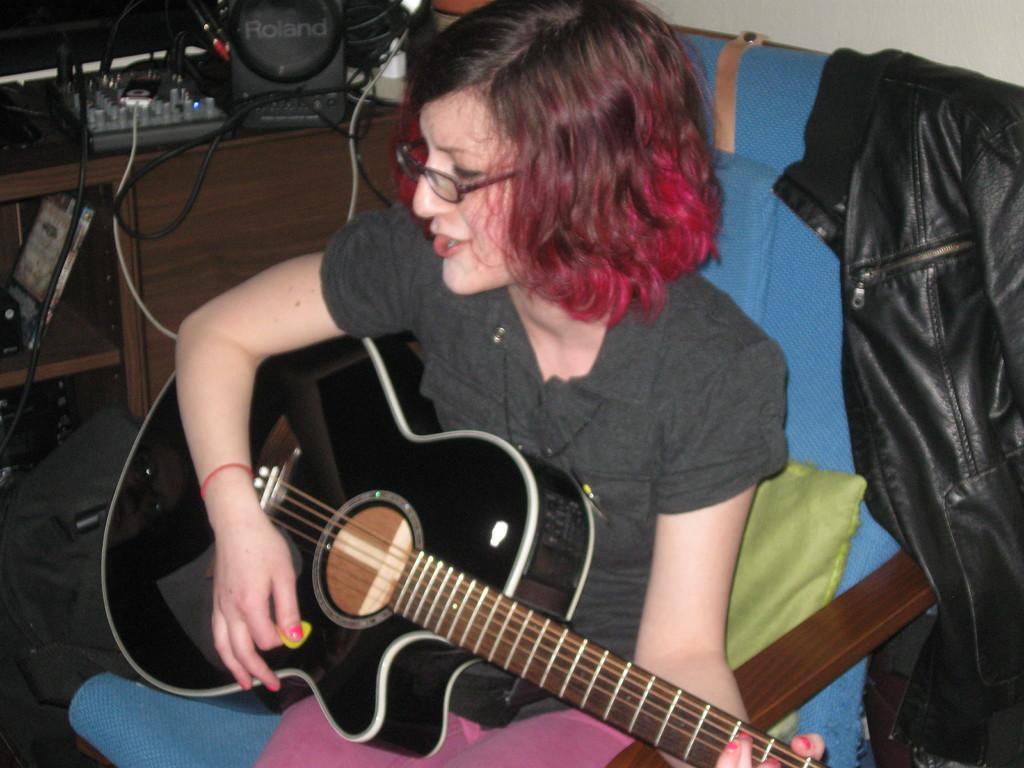Describe this image in one or two sentences. This picture shows a woman seated and playing guitar and singing and we see spectacles on her face and we see a chair and a pillow and a leather jacket and we see a table on the left 